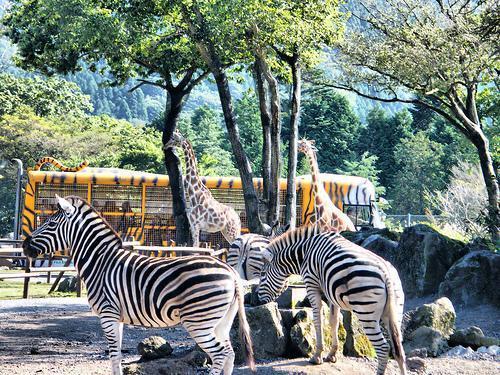How many buses?
Give a very brief answer. 1. 